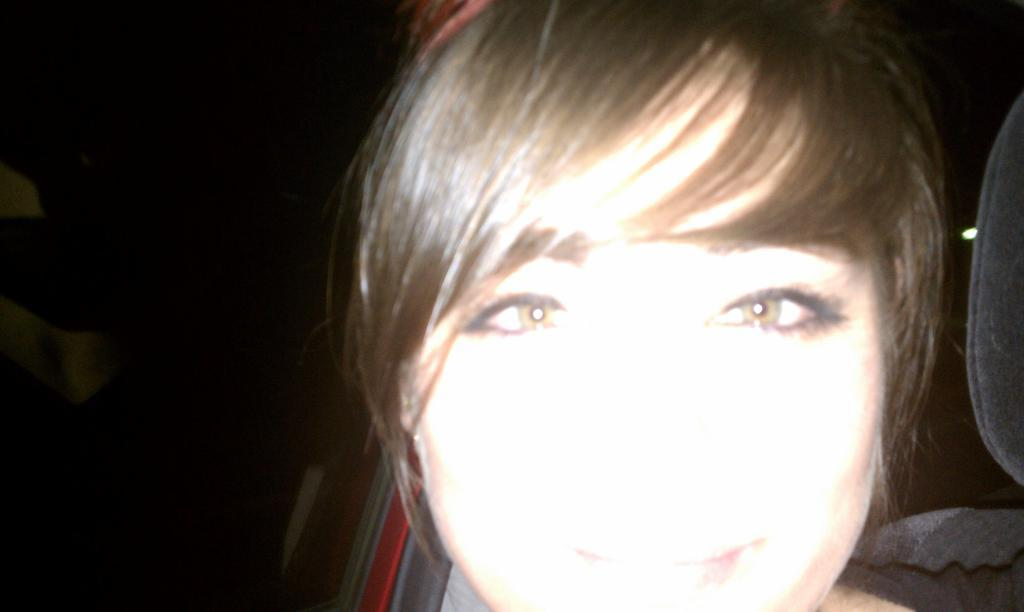Who is present in the image? There is a woman in the image. What can be observed about the background of the image? The background of the image is dark. What type of pencil is the woman holding in the image? There is no pencil present in the image. Can you see any bubbles floating around the woman in the image? There are no bubbles visible in the image. 